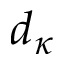Convert formula to latex. <formula><loc_0><loc_0><loc_500><loc_500>d _ { \kappa }</formula> 